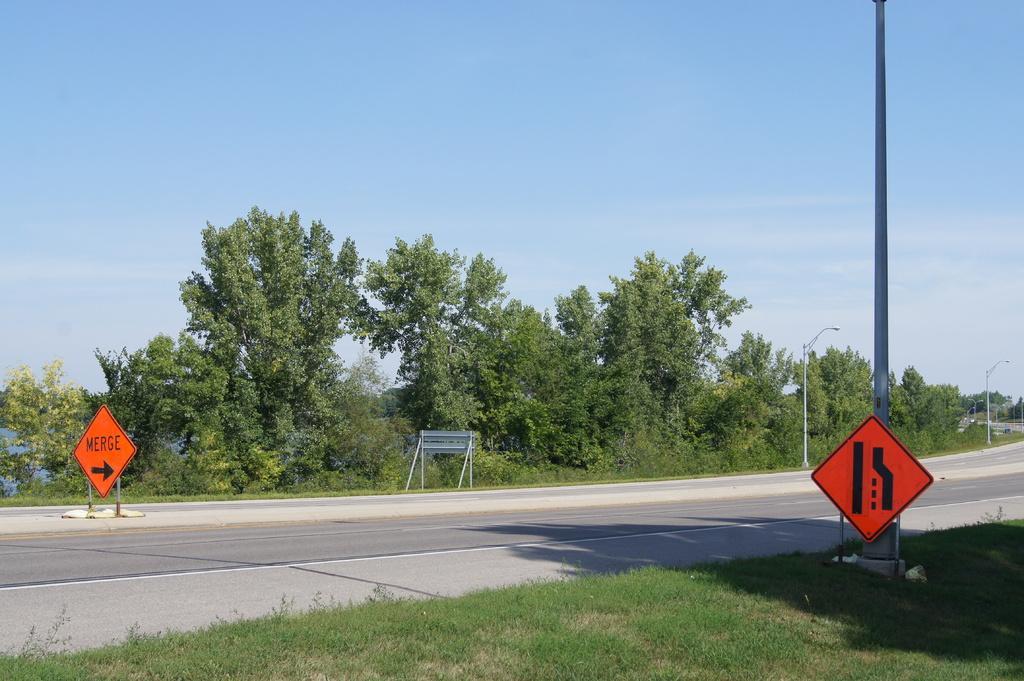In one or two sentences, can you explain what this image depicts? In the image we can see there is a ground covered with grass and there are sign boards kept on the footpath. In between there is a road, behind there are trees and street light poles on the footpath. There is a clear sky. 